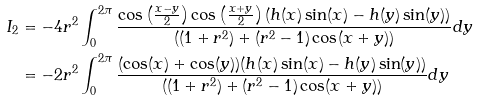<formula> <loc_0><loc_0><loc_500><loc_500>I _ { 2 } & = - 4 r ^ { 2 } \int _ { 0 } ^ { 2 \pi } \frac { \cos \left ( \frac { x - y } { 2 } \right ) \cos \left ( \frac { x + y } { 2 } \right ) ( h ( x ) \sin ( x ) - h ( y ) \sin ( y ) ) } { ( ( 1 + r ^ { 2 } ) + ( r ^ { 2 } - 1 ) \cos ( x + y ) ) } d y \\ & = - 2 r ^ { 2 } \int _ { 0 } ^ { 2 \pi } \frac { ( \cos ( x ) + \cos ( y ) ) ( h ( x ) \sin ( x ) - h ( y ) \sin ( y ) ) } { ( ( 1 + r ^ { 2 } ) + ( r ^ { 2 } - 1 ) \cos ( x + y ) ) } d y \\</formula> 